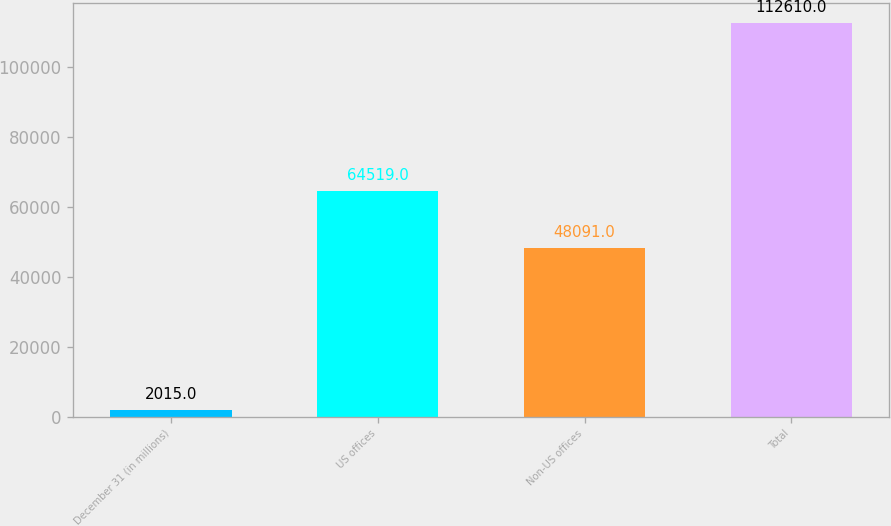Convert chart. <chart><loc_0><loc_0><loc_500><loc_500><bar_chart><fcel>December 31 (in millions)<fcel>US offices<fcel>Non-US offices<fcel>Total<nl><fcel>2015<fcel>64519<fcel>48091<fcel>112610<nl></chart> 